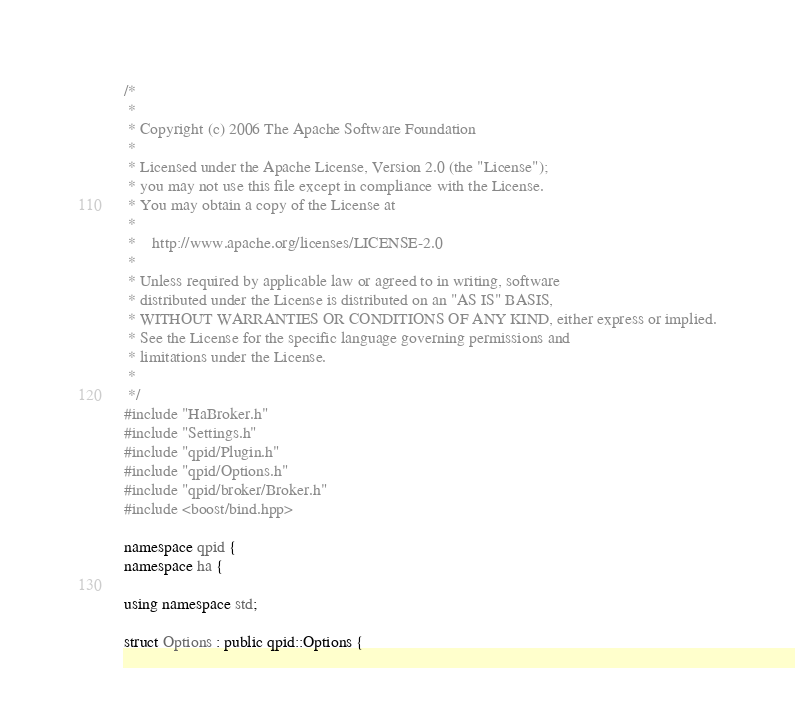<code> <loc_0><loc_0><loc_500><loc_500><_C++_>/*
 *
 * Copyright (c) 2006 The Apache Software Foundation
 *
 * Licensed under the Apache License, Version 2.0 (the "License");
 * you may not use this file except in compliance with the License.
 * You may obtain a copy of the License at
 *
 *    http://www.apache.org/licenses/LICENSE-2.0
 *
 * Unless required by applicable law or agreed to in writing, software
 * distributed under the License is distributed on an "AS IS" BASIS,
 * WITHOUT WARRANTIES OR CONDITIONS OF ANY KIND, either express or implied.
 * See the License for the specific language governing permissions and
 * limitations under the License.
 *
 */
#include "HaBroker.h"
#include "Settings.h"
#include "qpid/Plugin.h"
#include "qpid/Options.h"
#include "qpid/broker/Broker.h"
#include <boost/bind.hpp>

namespace qpid {
namespace ha {

using namespace std;

struct Options : public qpid::Options {</code> 